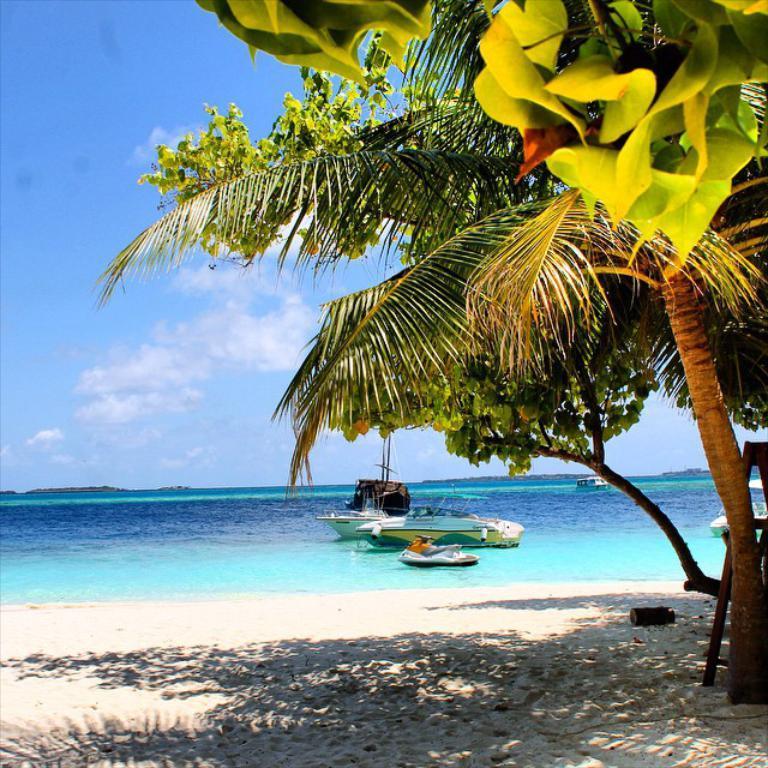Could you give a brief overview of what you see in this image? In the picture I can see the ships on the water. I can see the trees on the side of a beach on the right side. I can see the sand at the bottom of the picture. There are clouds in the sky. 